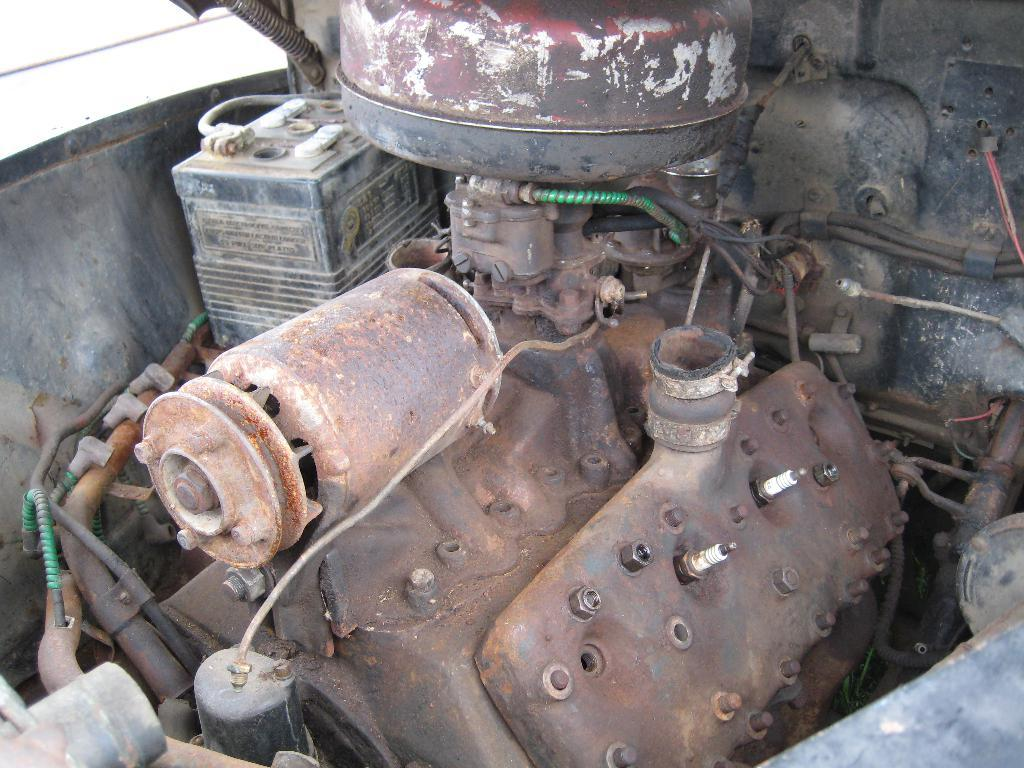What is the main subject of the image? The main subject of the image is a vehicle engine. Can you describe the condition of the vehicle engine? The vehicle engine is rusted. What type of thread is being used to repair the muscle in the image? There is no thread or muscle present in the image; it features a rusted vehicle engine. 